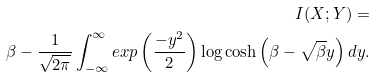<formula> <loc_0><loc_0><loc_500><loc_500>I ( X ; Y ) = \\ \beta - \frac { 1 } { \sqrt { 2 \pi } } \int _ { - \infty } ^ { \infty } e x p \left ( \frac { - y ^ { 2 } } { 2 } \right ) \log \cosh \left ( \beta - \sqrt { \beta } y \right ) d y .</formula> 